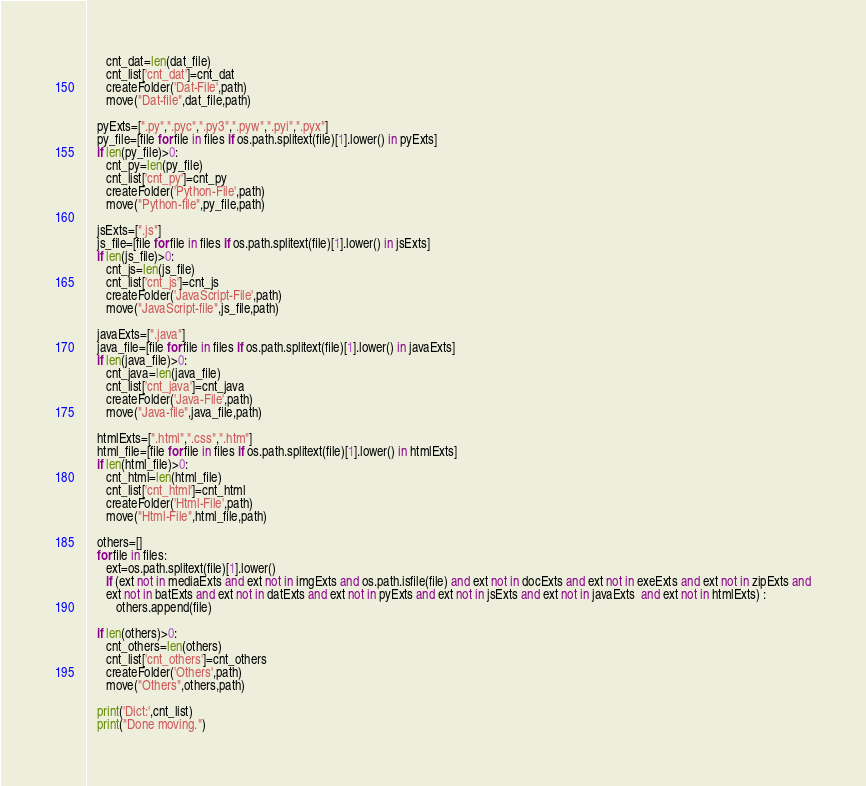<code> <loc_0><loc_0><loc_500><loc_500><_Python_>      cnt_dat=len(dat_file)
      cnt_list['cnt_dat']=cnt_dat
      createFolder('Dat-File',path)
      move("Dat-file",dat_file,path)

   pyExts=[".py",".pyc",".py3",".pyw",".pyi",".pyx"]
   py_file=[file for file in files if os.path.splitext(file)[1].lower() in pyExts]
   if len(py_file)>0:
      cnt_py=len(py_file)
      cnt_list['cnt_py']=cnt_py
      createFolder('Python-File',path)
      move("Python-file",py_file,path)

   jsExts=[".js"]
   js_file=[file for file in files if os.path.splitext(file)[1].lower() in jsExts]
   if len(js_file)>0:
      cnt_js=len(js_file)
      cnt_list['cnt_js']=cnt_js
      createFolder('JavaScript-File',path)
      move("JavaScript-file",js_file,path)

   javaExts=[".java"]
   java_file=[file for file in files if os.path.splitext(file)[1].lower() in javaExts]
   if len(java_file)>0:
      cnt_java=len(java_file)
      cnt_list['cnt_java']=cnt_java
      createFolder('Java-File',path)
      move("Java-file",java_file,path)

   htmlExts=[".html",".css",".htm"]
   html_file=[file for file in files if os.path.splitext(file)[1].lower() in htmlExts]
   if len(html_file)>0:
      cnt_html=len(html_file)
      cnt_list['cnt_html']=cnt_html
      createFolder('Html-File',path)
      move("Html-File",html_file,path)

   others=[]
   for file in files:
      ext=os.path.splitext(file)[1].lower()
      if (ext not in mediaExts and ext not in imgExts and os.path.isfile(file) and ext not in docExts and ext not in exeExts and ext not in zipExts and
      ext not in batExts and ext not in datExts and ext not in pyExts and ext not in jsExts and ext not in javaExts  and ext not in htmlExts) :
         others.append(file)
   
   if len(others)>0:
      cnt_others=len(others)
      cnt_list['cnt_others']=cnt_others
      createFolder('Others',path)
      move("Others",others,path)
  
   print('Dict:',cnt_list)   
   print("Done moving.")
</code> 